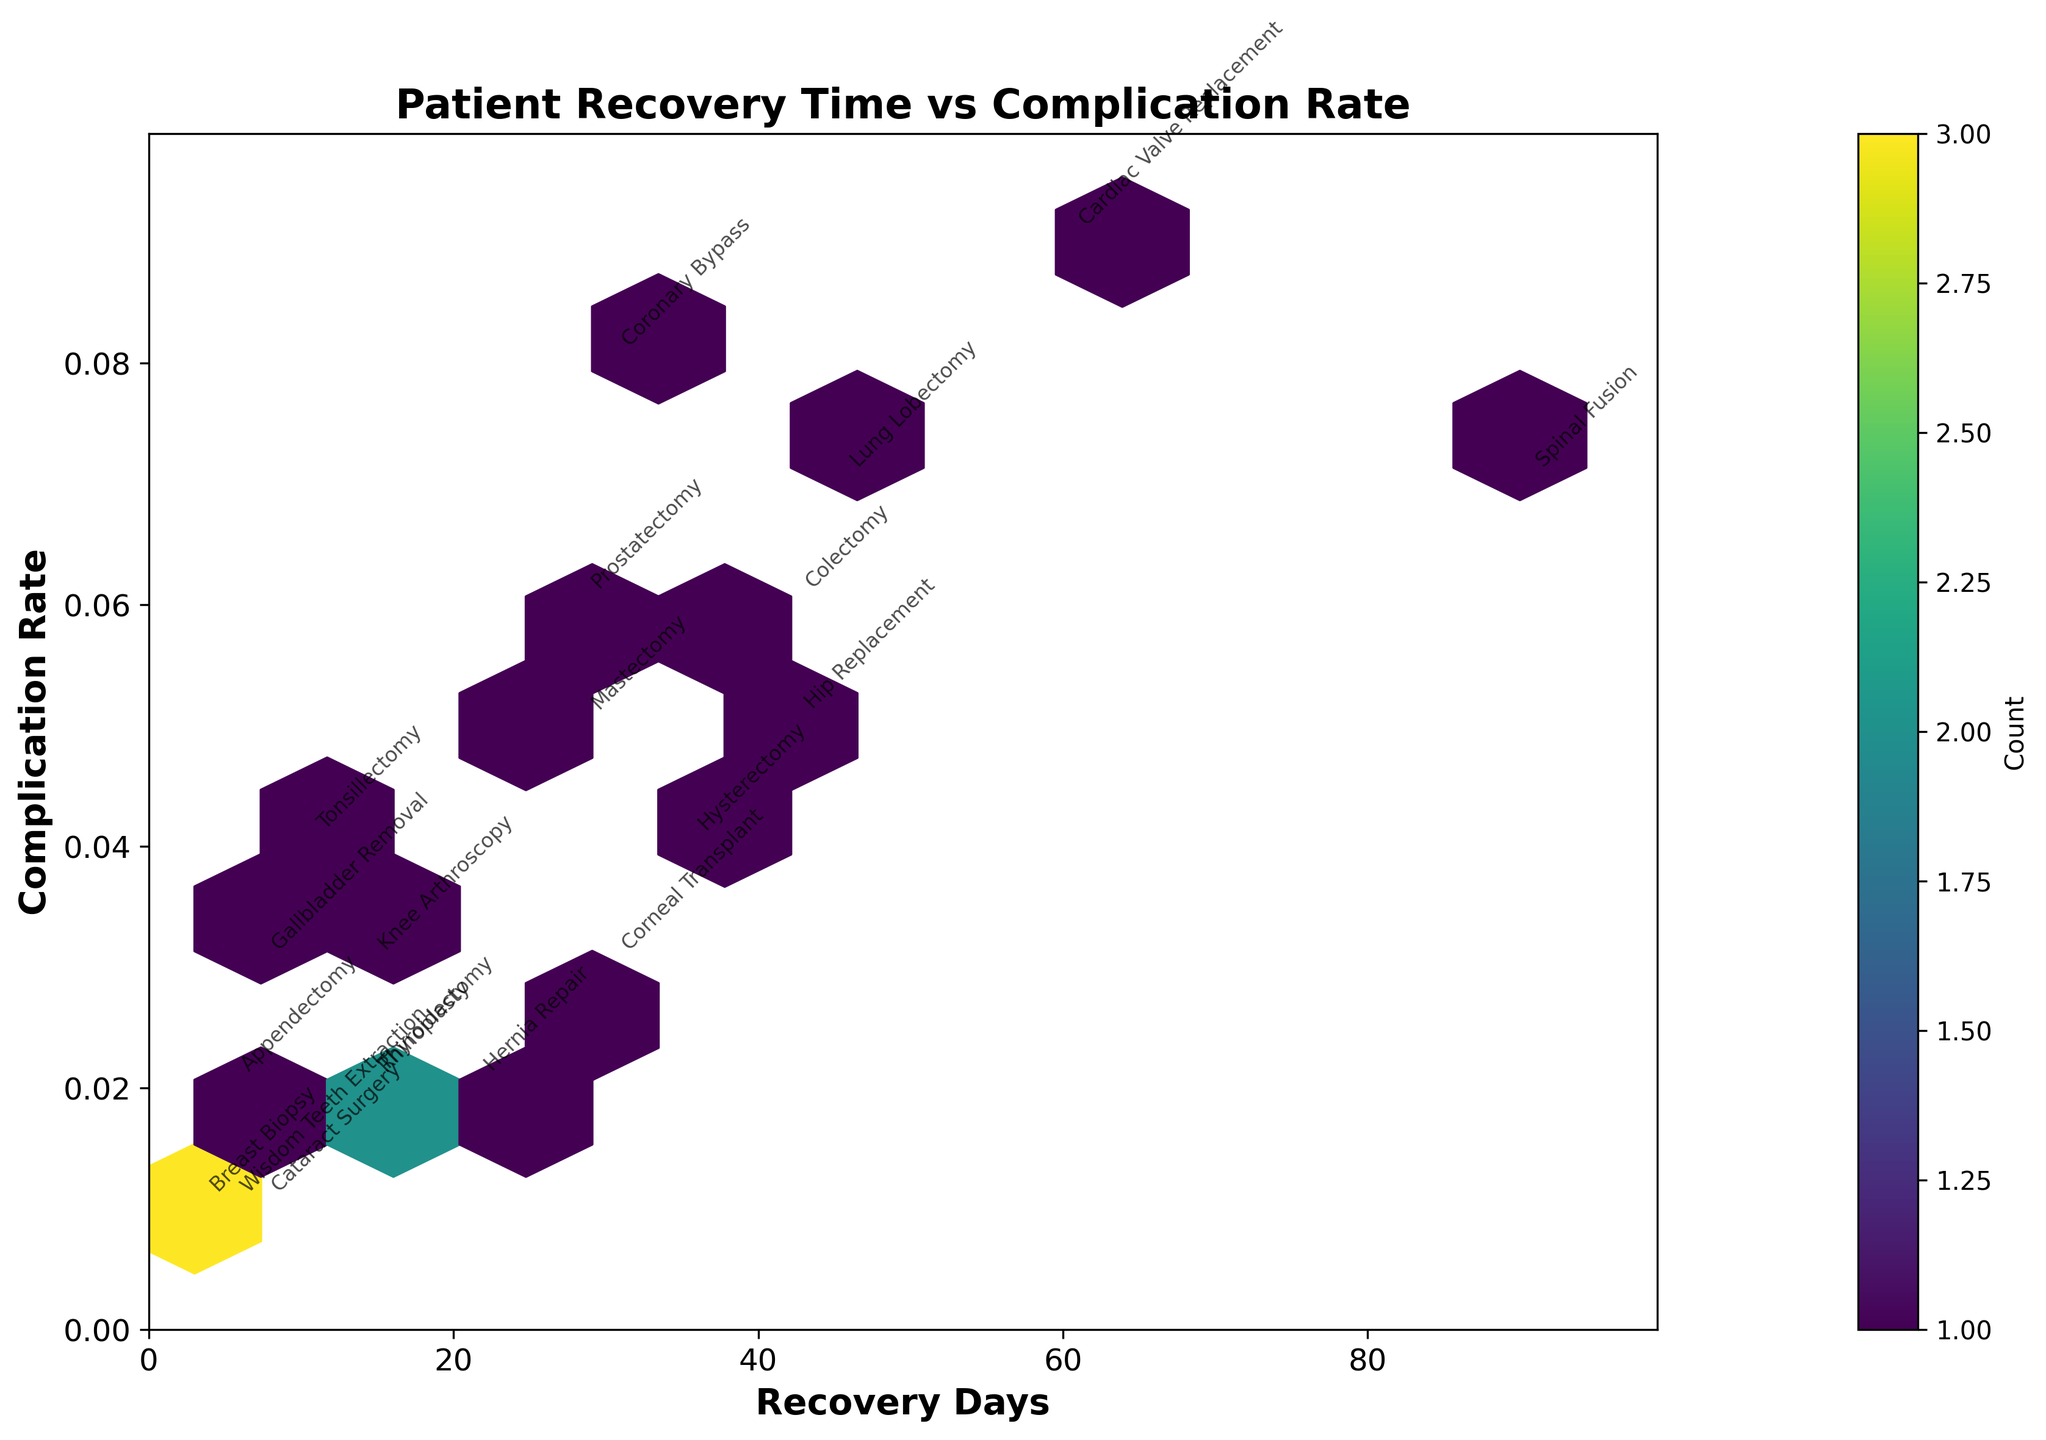What is the title of the plot? The title can be found at the top of the plot in bold text. It reads "Patient Recovery Time vs Complication Rate".
Answer: Patient Recovery Time vs Complication Rate What are the x-axis and y-axis labels? The labels of the axes are located next to the respective axes. The x-axis is labeled "Recovery Days" and the y-axis is labeled "Complication Rate".
Answer: Recovery Days; Complication Rate How many procedures have a recovery time of less than 10 days? To find this, look for hexagons located within the range of less than 10 on the x-axis. Count the procedures annotated or located within these hexagons. Procedures like Appendectomy, Breast Biopsy, Cataract Surgery, Wisdom Teeth Extraction, and Gallbladder Removal fall into this range.
Answer: 5 Which procedure has the highest complication rate, and what is it? The highest complication rate corresponds to the procedure found near the top of the y-axis. Cardiac Valve Replacement has the highest rate, which is 0.09.
Answer: Cardiac Valve Replacement, 0.09 Are there more procedures with a recovery time less than 30 days or more than 30 days? Identify the recovery days of each procedure by looking along the x-axis and categorize them into two groups: less than 30 days and more than 30 days. Count the procedures in both groups to determine which is higher. There are 12 procedures with less than 30 days and 8 procedures with more than 30 days.
Answer: Less than 30 days Which procedure has the longest recovery time? The procedure with the longest recovery time corresponds to the furthest point on the right along the x-axis. Spinal Fusion has the longest recovery time at 90 days.
Answer: Spinal Fusion, 90 days How many procedures have a complication rate of 0.03? Locate the hexagons along the y-axis value of 0.03 and count the number of procedures tagged at these points. Procedures like Knee Arthroscopy, Gallbladder Removal, and Corneal Transplant have a complication rate of 0.03.
Answer: 3 Is there a noticeable correlation between the recovery time and complication rate? Observe the overall pattern of the hexagons to see if there's a trend. There doesn't seem to be a strong correlation; the data points appear scattered.
Answer: No Which procedures have the same recovery time of 14 days? Look for the annotations for procedures located at the x-axis value of 14. Knee Arthroscopy, Thyroidectomy, and Rhinoplasty all have a recovery time of 14 days.
Answer: Knee Arthroscopy, Thyroidectomy, Rhinoplasty What is the recovery time range for procedures with a complication rate below 0.04? Identify the procedures located below the y-axis value of 0.04 and list their recovery times. The recovery times range from 3 to 30 days for procedures like Appendectomy, Knee Arthroscopy, Cataract Surgery, Gallbladder Removal, Breast Biopsy, and Corneal Transplant.
Answer: 3 to 30 days 